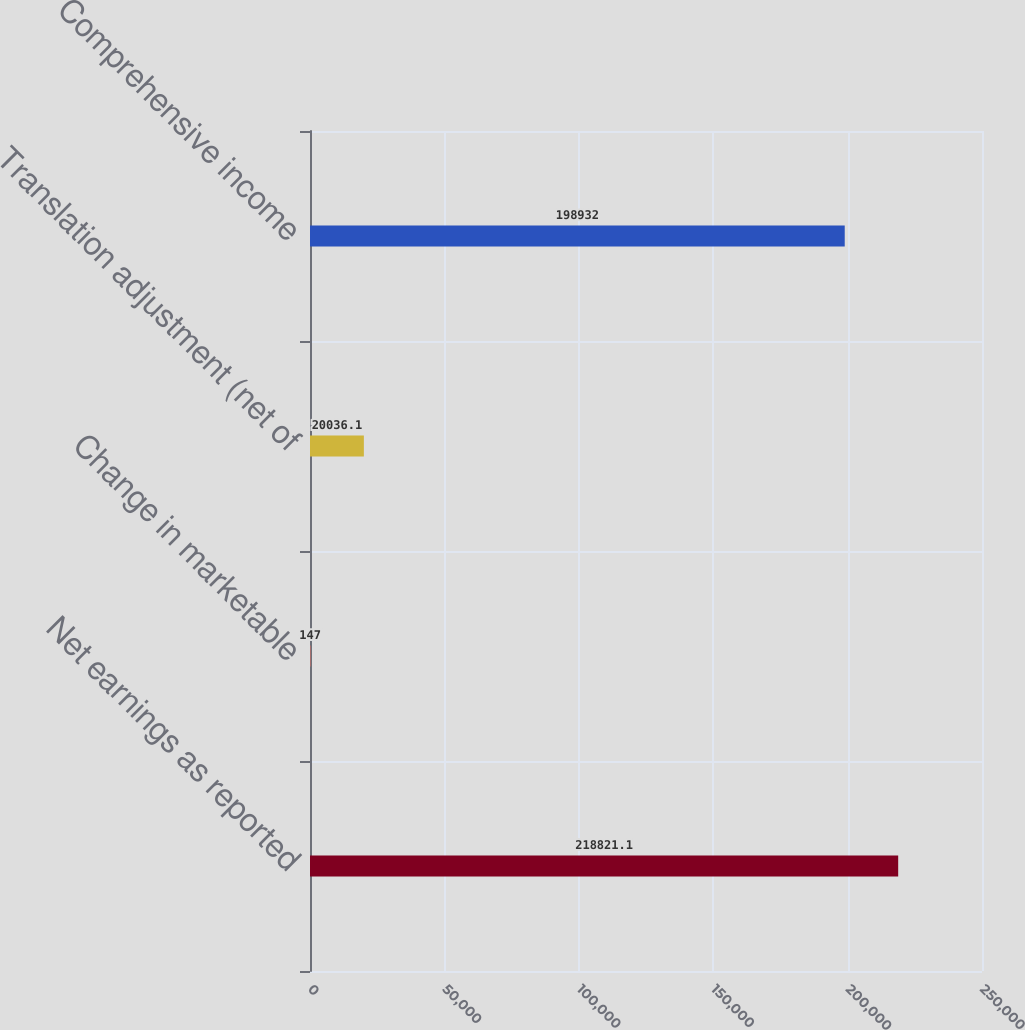<chart> <loc_0><loc_0><loc_500><loc_500><bar_chart><fcel>Net earnings as reported<fcel>Change in marketable<fcel>Translation adjustment (net of<fcel>Comprehensive income<nl><fcel>218821<fcel>147<fcel>20036.1<fcel>198932<nl></chart> 